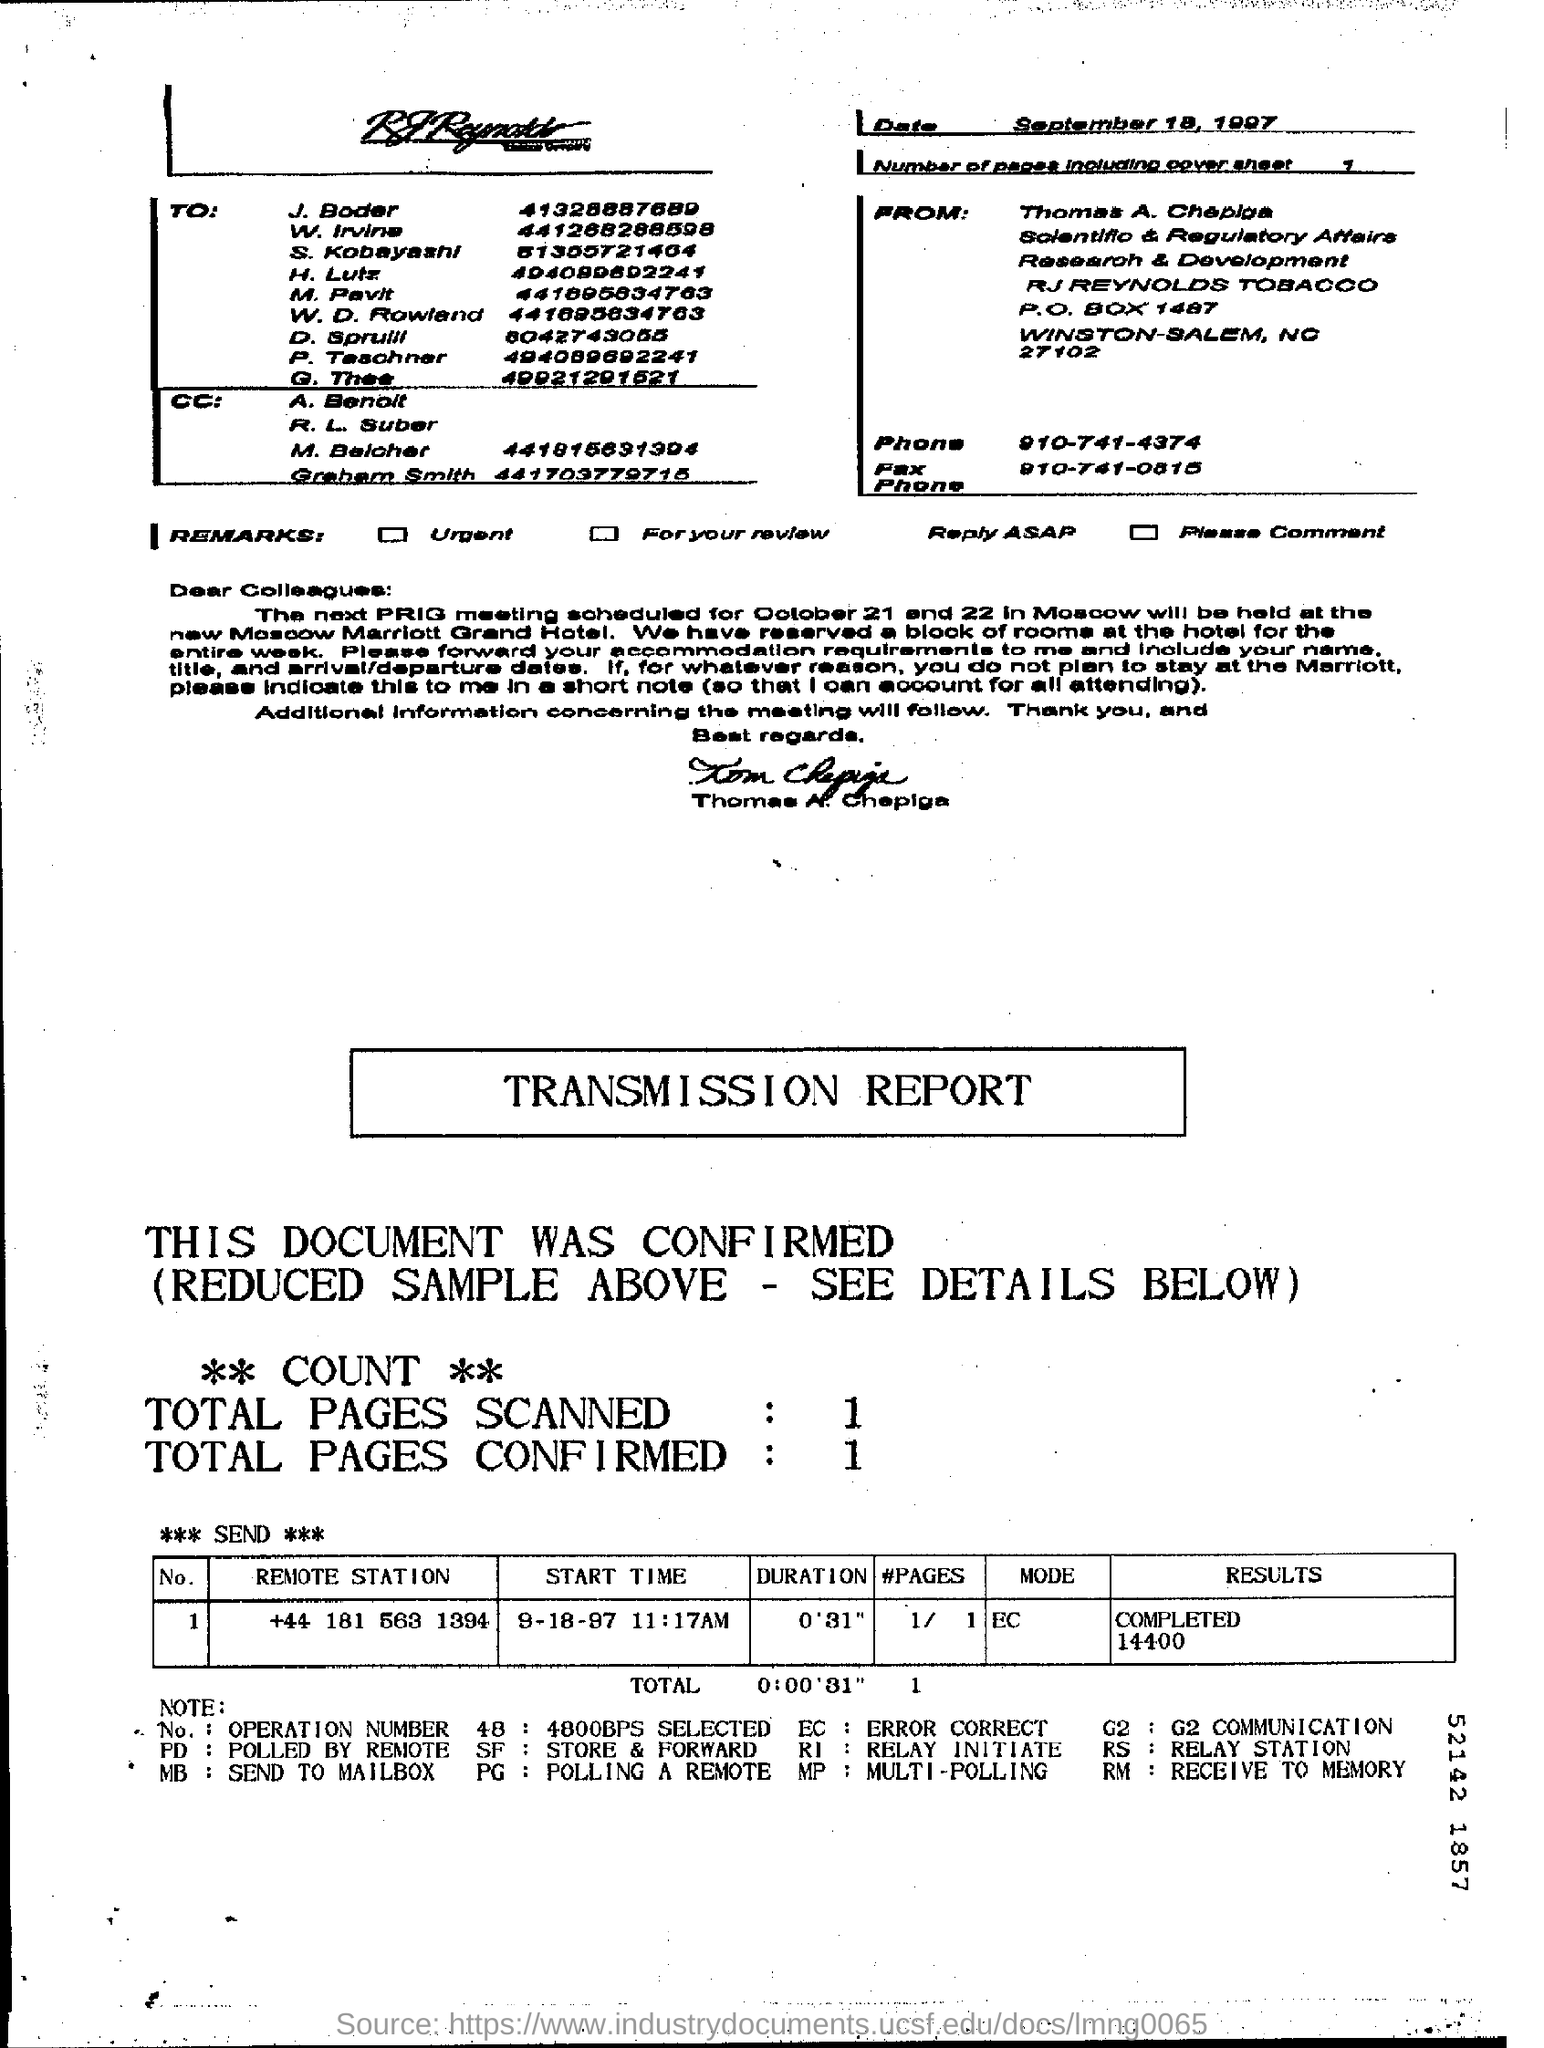What is the Date?
Make the answer very short. September 18, 1997. What are the number of pages including cover sheet?
Ensure brevity in your answer.  1. When is the next PRIG meeting scheduled for?
Provide a succinct answer. October 21 and 22. What is the result for the remote station "+44 181 563 1394"?
Offer a terse response. Completed 14400. What is the mode for the remote station "+44 181 563 1394"?
Keep it short and to the point. EC. What is the Total pages scanned?
Provide a short and direct response. 1. What are the Total Pages confirmed?
Give a very brief answer. 1. 